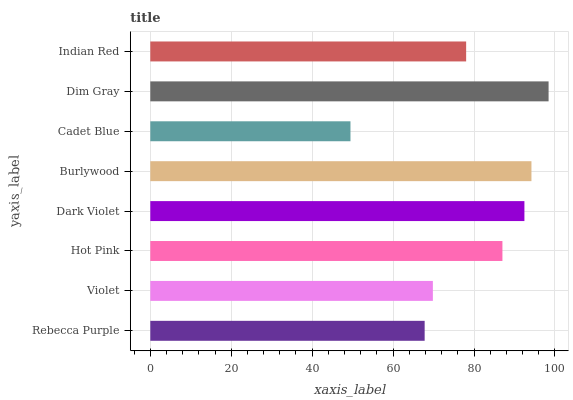Is Cadet Blue the minimum?
Answer yes or no. Yes. Is Dim Gray the maximum?
Answer yes or no. Yes. Is Violet the minimum?
Answer yes or no. No. Is Violet the maximum?
Answer yes or no. No. Is Violet greater than Rebecca Purple?
Answer yes or no. Yes. Is Rebecca Purple less than Violet?
Answer yes or no. Yes. Is Rebecca Purple greater than Violet?
Answer yes or no. No. Is Violet less than Rebecca Purple?
Answer yes or no. No. Is Hot Pink the high median?
Answer yes or no. Yes. Is Indian Red the low median?
Answer yes or no. Yes. Is Burlywood the high median?
Answer yes or no. No. Is Violet the low median?
Answer yes or no. No. 